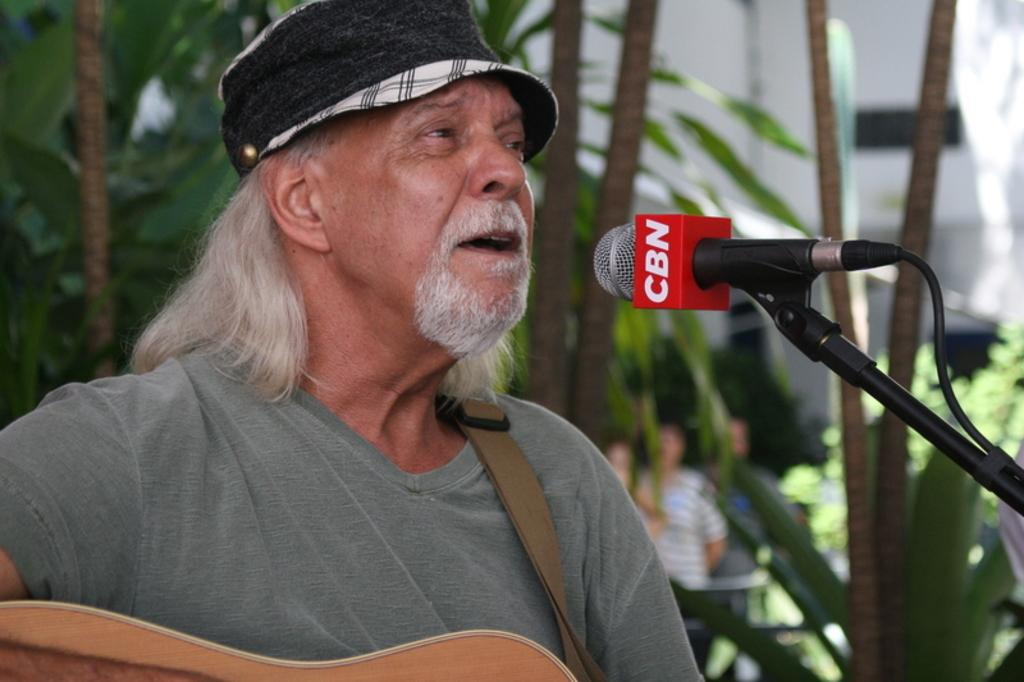Who is the main subject in the image? There is a person in the image. What is the person wearing on their head? The person is wearing a hat. What is the person doing in the image? The person is playing a guitar. Where is the person positioned in relation to the microphone? The person is in front of a microphone. What can be seen in the background of the image? There are trees in the background of the image. What type of structure is being built with chalk in the image? There is no structure being built with chalk in the image; it features a person playing a guitar in front of a microphone. Can you describe the person's tongue while they are playing the guitar? There is no information about the person's tongue in the image, as it focuses on their hat, guitar, and microphone. 